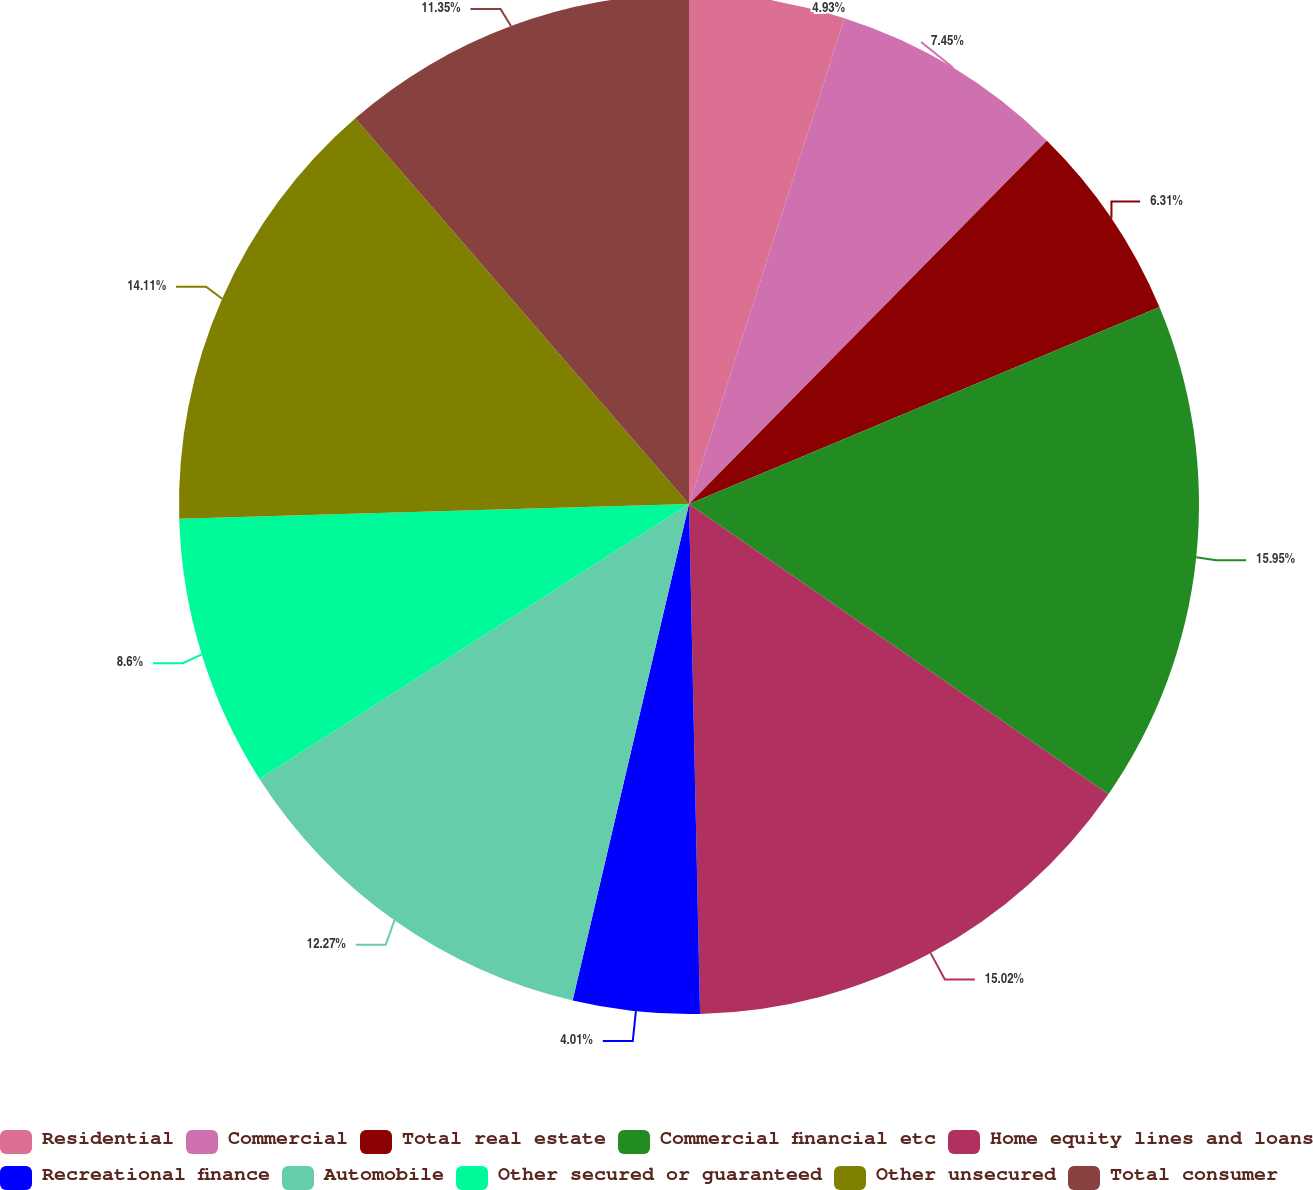<chart> <loc_0><loc_0><loc_500><loc_500><pie_chart><fcel>Residential<fcel>Commercial<fcel>Total real estate<fcel>Commercial financial etc<fcel>Home equity lines and loans<fcel>Recreational finance<fcel>Automobile<fcel>Other secured or guaranteed<fcel>Other unsecured<fcel>Total consumer<nl><fcel>4.93%<fcel>7.45%<fcel>6.31%<fcel>15.94%<fcel>15.02%<fcel>4.01%<fcel>12.27%<fcel>8.6%<fcel>14.11%<fcel>11.35%<nl></chart> 